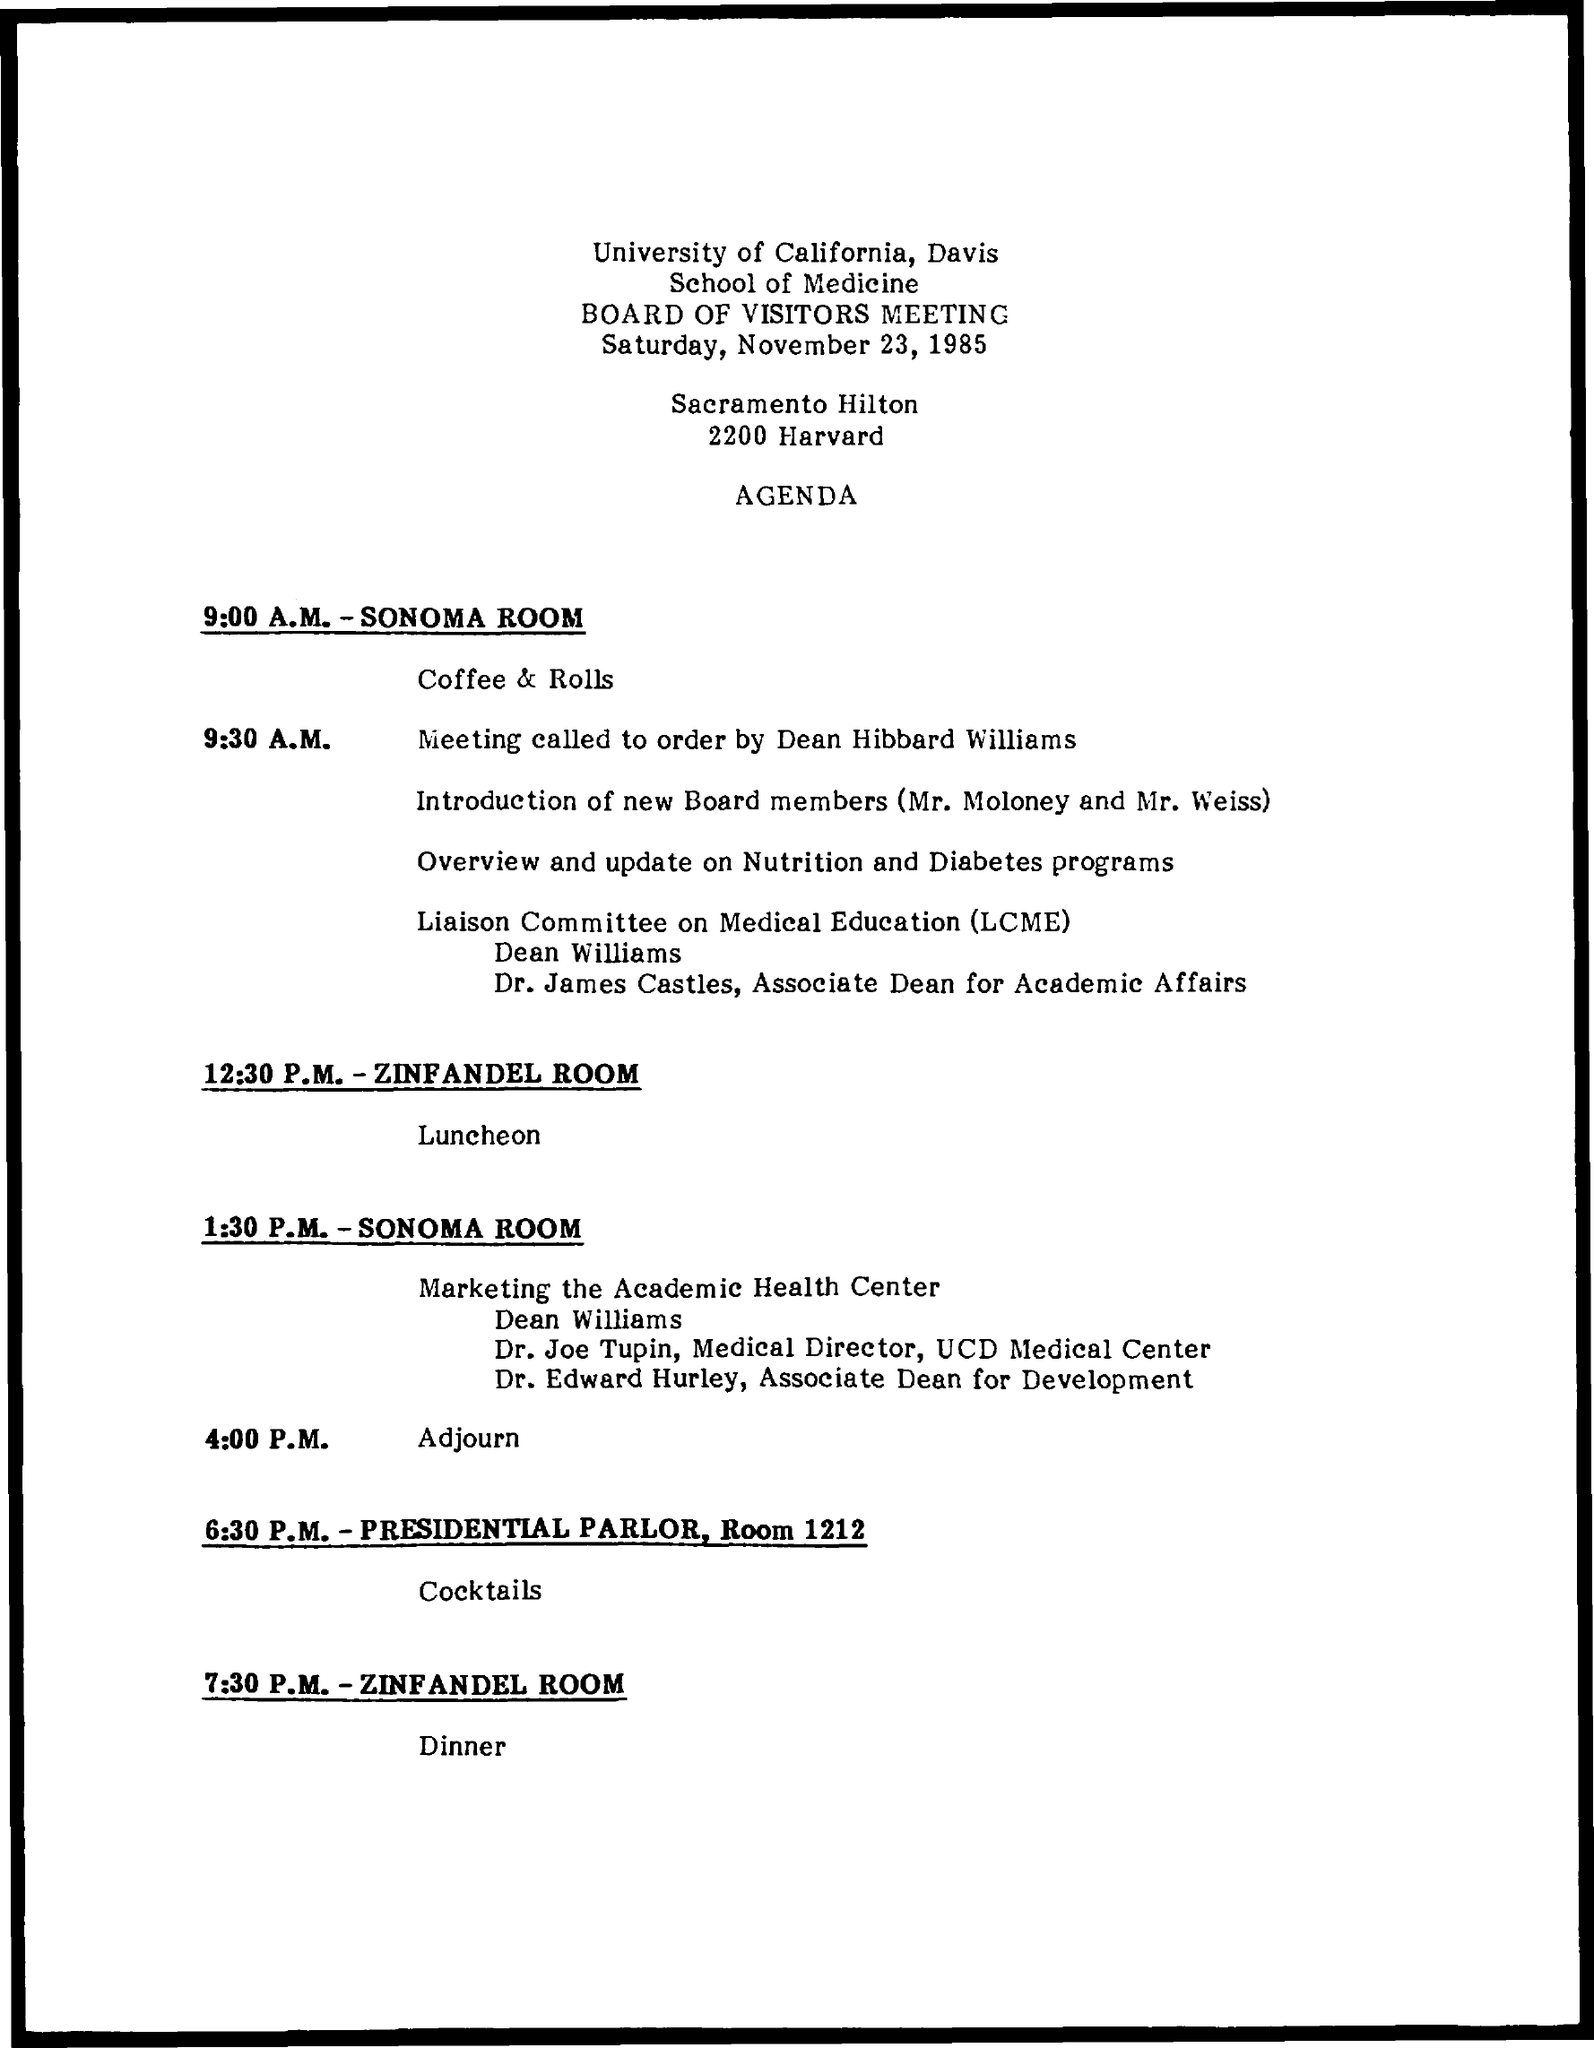What is the date of  Board of visitors meeting
Provide a short and direct response. Saturday, November 23, 1985. What is the full form of LCME
Offer a terse response. Liaison Committee on Medical Education. 